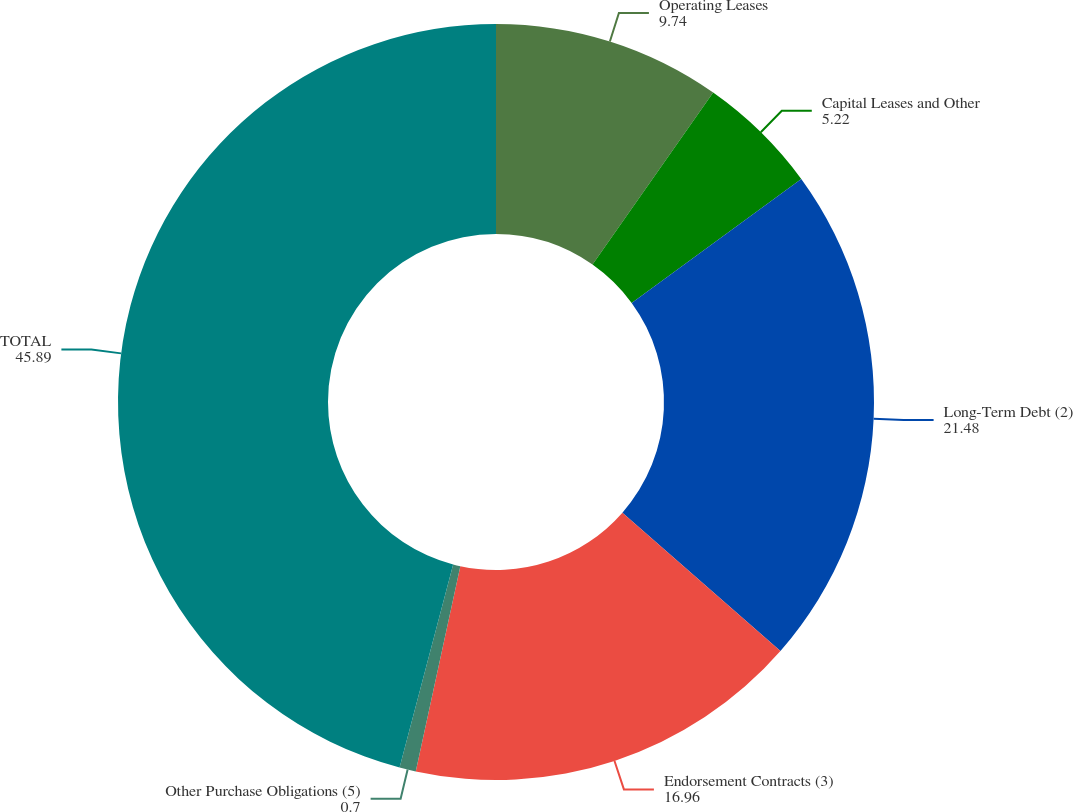<chart> <loc_0><loc_0><loc_500><loc_500><pie_chart><fcel>Operating Leases<fcel>Capital Leases and Other<fcel>Long-Term Debt (2)<fcel>Endorsement Contracts (3)<fcel>Other Purchase Obligations (5)<fcel>TOTAL<nl><fcel>9.74%<fcel>5.22%<fcel>21.48%<fcel>16.96%<fcel>0.7%<fcel>45.89%<nl></chart> 